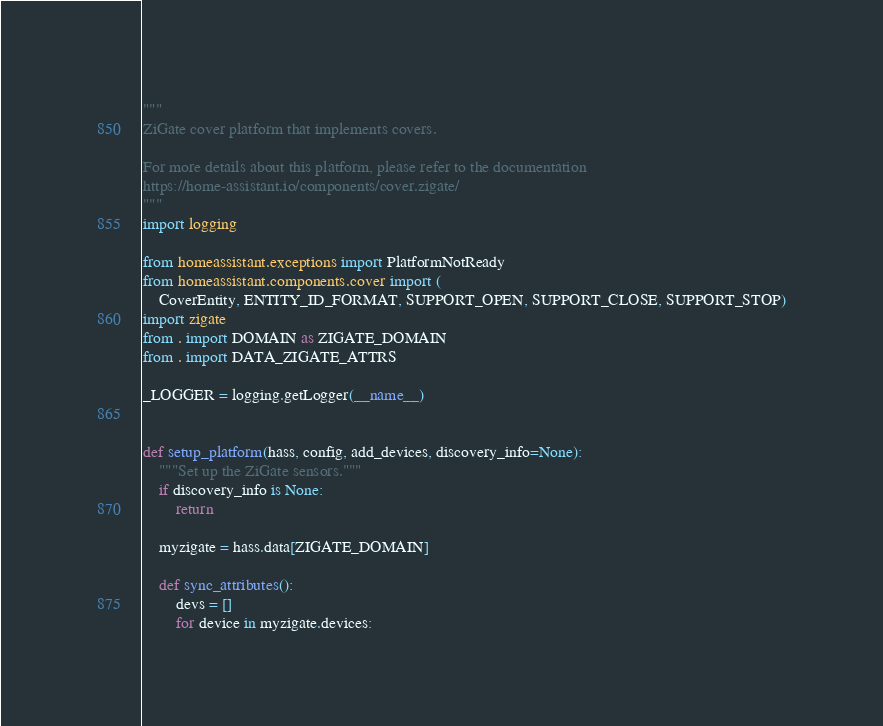<code> <loc_0><loc_0><loc_500><loc_500><_Python_>"""
ZiGate cover platform that implements covers.

For more details about this platform, please refer to the documentation
https://home-assistant.io/components/cover.zigate/
"""
import logging

from homeassistant.exceptions import PlatformNotReady
from homeassistant.components.cover import (
    CoverEntity, ENTITY_ID_FORMAT, SUPPORT_OPEN, SUPPORT_CLOSE, SUPPORT_STOP)
import zigate
from . import DOMAIN as ZIGATE_DOMAIN
from . import DATA_ZIGATE_ATTRS

_LOGGER = logging.getLogger(__name__)


def setup_platform(hass, config, add_devices, discovery_info=None):
    """Set up the ZiGate sensors."""
    if discovery_info is None:
        return

    myzigate = hass.data[ZIGATE_DOMAIN]

    def sync_attributes():
        devs = []
        for device in myzigate.devices:</code> 